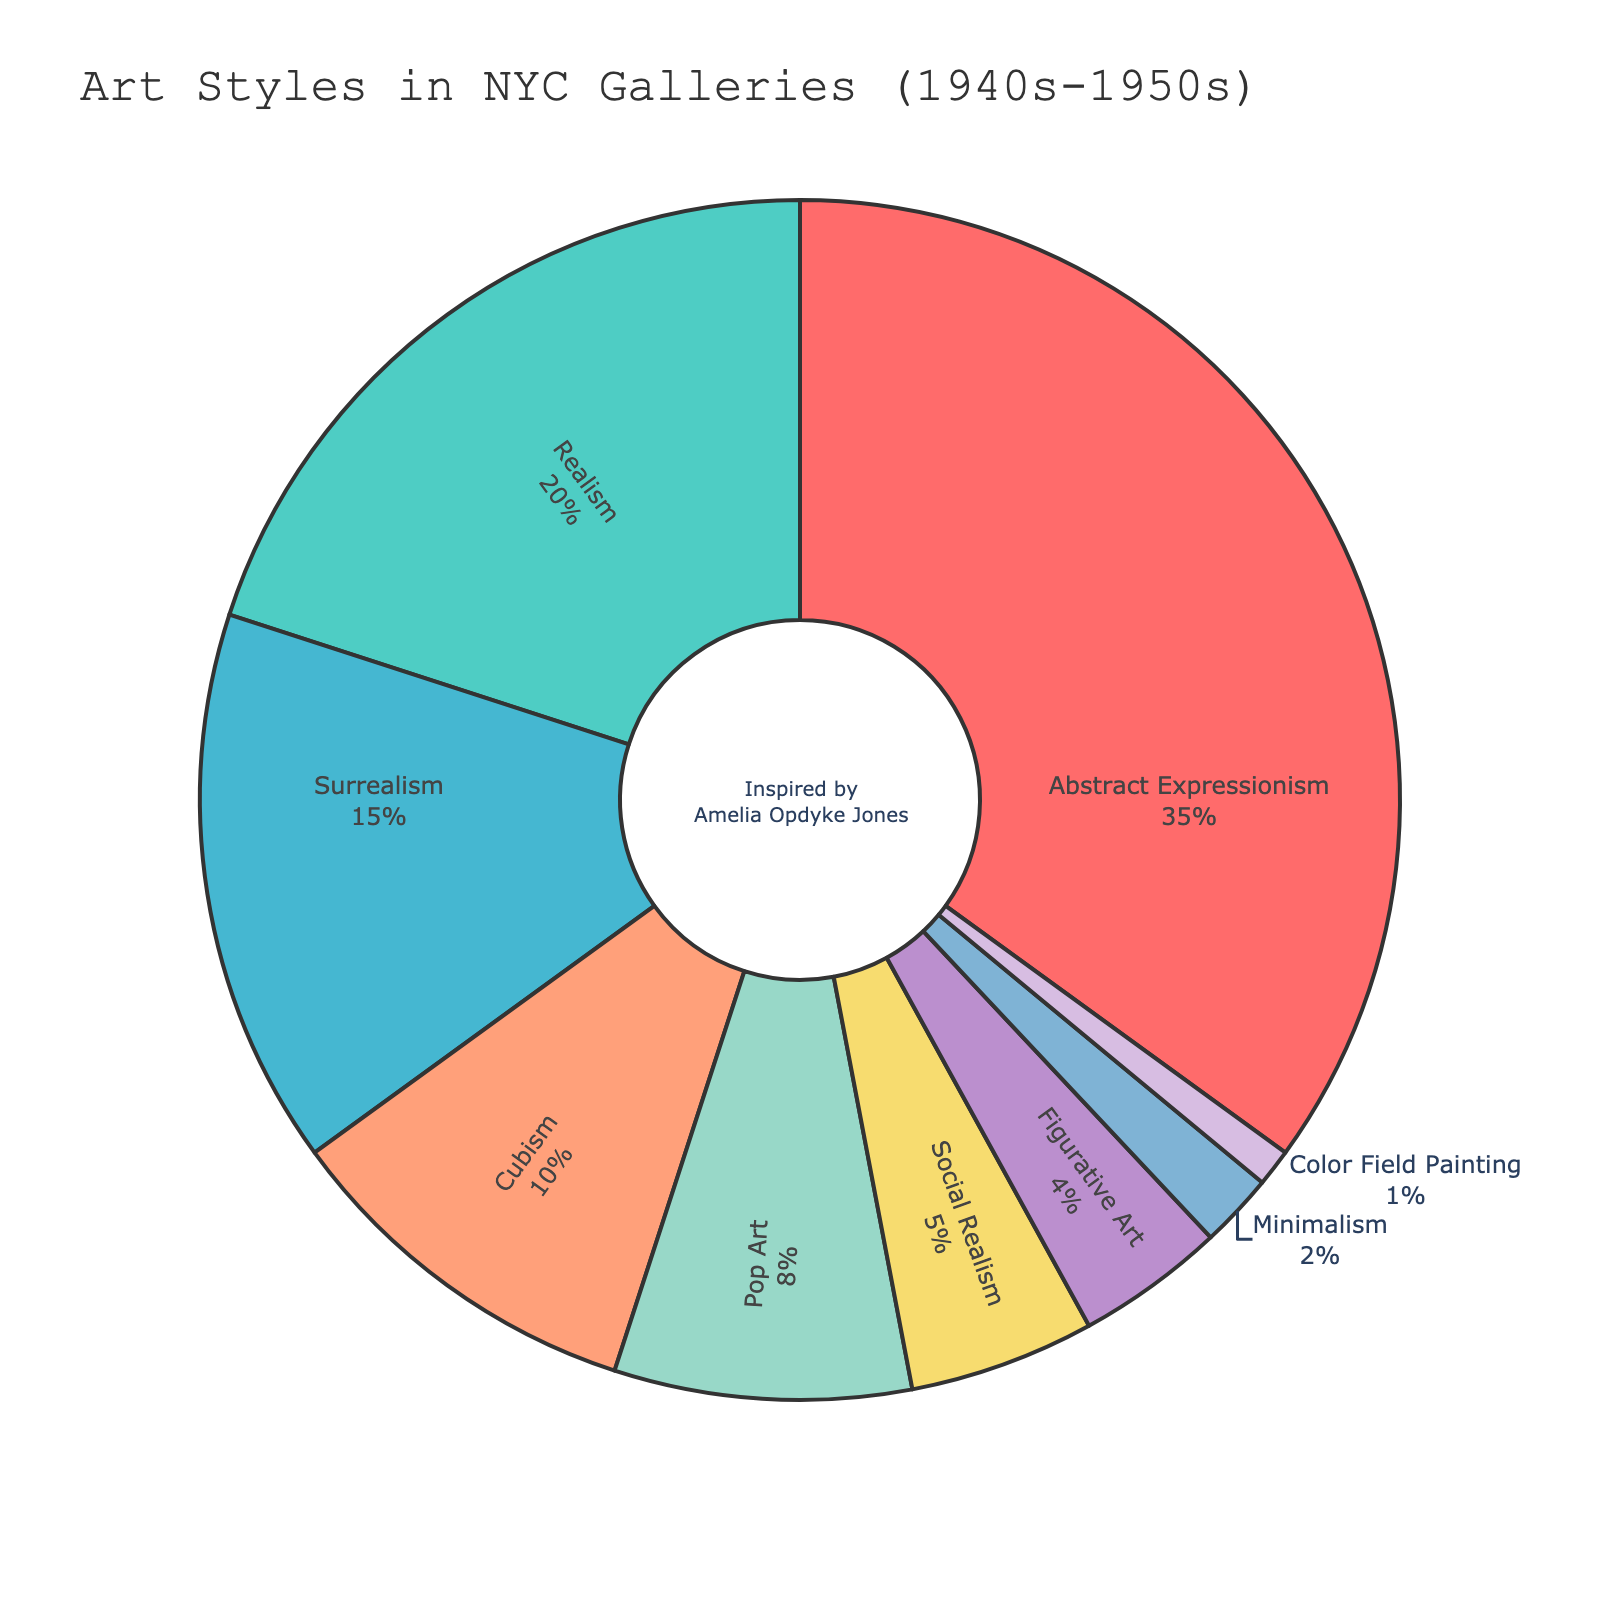What's the proportion of Abstract Expressionism art style in NYC galleries during the 1940s-1950s? The pie chart shows percentages, and Abstract Expressionism has a slice marked with 35%.
Answer: 35% Which art style has a higher representation, Cubism or Surrealism? Compare the percentage slices of Cubism and Surrealism. Cubism is 10%, and Surrealism is 15%. Hence, Surrealism has a higher representation.
Answer: Surrealism What's the combined percentage of Realism and Pop Art? Add the percentages of Realism and Pop Art. Realism has 20%, and Pop Art has 8%. Therefore, 20% + 8% = 28%.
Answer: 28% How much larger in percentage is Abstract Expressionism compared to Realism? Subtract the percentage of Realism from Abstract Expressionism. Abstract Expressionism is 35%, and Realism is 20%, so 35% - 20% = 15%.
Answer: 15% Which art styles together make up more than 50% of the representation? Add the percentages of each art style until the sum exceeds 50%. Abstract Expressionism is 35%, and adding Realism at 20% gives 55%. Thus, Abstract Expressionism and Realism together make more than 50%.
Answer: Abstract Expressionism and Realism Which segment is represented by the color blue in the pie chart? The chart uses different colors for different segments. Notably, the segment for Surrealism is colored blue.
Answer: Surrealism Is the representation of Minimalism higher or lower than Figural Art? Compare their percentages from the chart. Minimalism has 2%, while Figural Art has 4%. Thus, Minimalism has a lower representation.
Answer: Lower What is the total percentage represented by Social Realism and Color Field Painting combined? Add the percentages of Social Realism and Color Field Painting. Social Realism is 5%, and Color Field Painting is 1%. Therefore, 5% + 1% = 6%.
Answer: 6% 